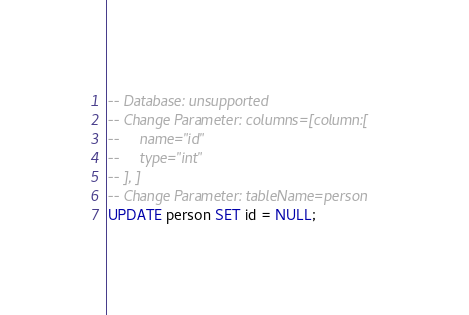<code> <loc_0><loc_0><loc_500><loc_500><_SQL_>-- Database: unsupported
-- Change Parameter: columns=[column:[
--     name="id"
--     type="int"
-- ], ]
-- Change Parameter: tableName=person
UPDATE person SET id = NULL;
</code> 